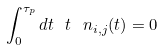<formula> <loc_0><loc_0><loc_500><loc_500>\int _ { 0 } ^ { \tau _ { p } } d t \ t \ n _ { i , j } ( t ) = 0</formula> 